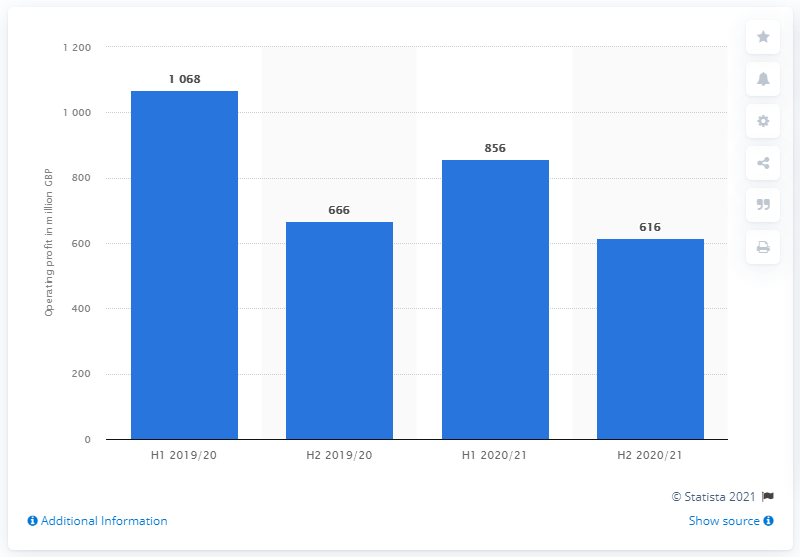Identify some key points in this picture. British Telecom reported a profit of 616 million British pounds in the second half of the 2020/2021 fiscal year. 